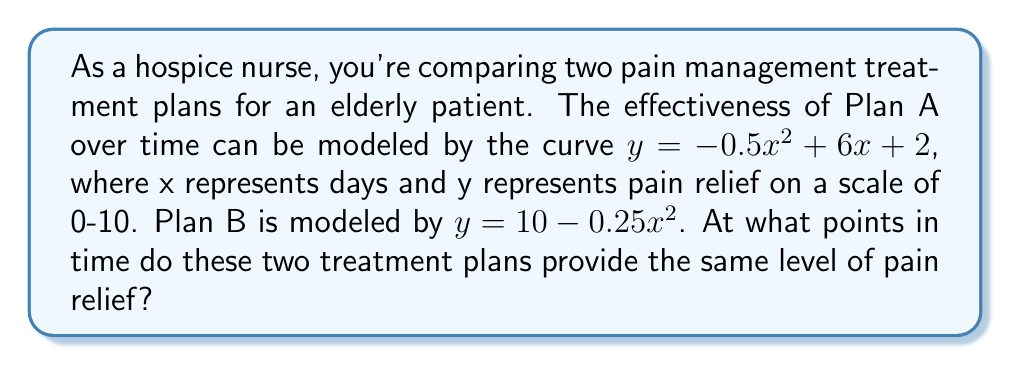Can you solve this math problem? To find the intersection points of these two curves, we need to solve the equation:

$-0.5x^2 + 6x + 2 = 10 - 0.25x^2$

Step 1: Rearrange the equation to standard form
$-0.5x^2 + 6x + 2 - (10 - 0.25x^2) = 0$
$-0.25x^2 + 6x - 8 = 0$

Step 2: Multiply all terms by 4 to eliminate fractions
$-x^2 + 24x - 32 = 0$

Step 3: Apply the quadratic formula $x = \frac{-b \pm \sqrt{b^2 - 4ac}}{2a}$
Where $a = -1$, $b = 24$, and $c = -32$

$x = \frac{-24 \pm \sqrt{24^2 - 4(-1)(-32)}}{2(-1)}$

Step 4: Simplify
$x = \frac{-24 \pm \sqrt{576 - 128}}{-2}$
$x = \frac{-24 \pm \sqrt{448}}{-2}$
$x = \frac{-24 \pm 16\sqrt{7}}{-2}$

Step 5: Solve for the two x values
$x_1 = \frac{-24 + 16\sqrt{7}}{-2} = 12 - 8\sqrt{7}$
$x_2 = \frac{-24 - 16\sqrt{7}}{-2} = 12 + 8\sqrt{7}$

These x values represent the days at which the two treatment plans provide the same level of pain relief.
Answer: $x_1 = 12 - 8\sqrt{7}$, $x_2 = 12 + 8\sqrt{7}$ 